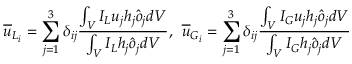<formula> <loc_0><loc_0><loc_500><loc_500>\overline { u } _ { L _ { i } } = \sum _ { j = 1 } ^ { 3 } \delta _ { i j } \frac { \int _ { V } I _ { L } u _ { j } h _ { j } \hat { o } _ { j } d V } { \int _ { V } I _ { L } h _ { j } \hat { o } _ { j } d V } , \, \overline { u } _ { G _ { i } } = \sum _ { j = 1 } ^ { 3 } \delta _ { i j } \frac { \int _ { V } I _ { G } u _ { j } h _ { j } \hat { o } _ { j } d V } { \int _ { V } I _ { G } h _ { j } \hat { o } _ { j } d V }</formula> 